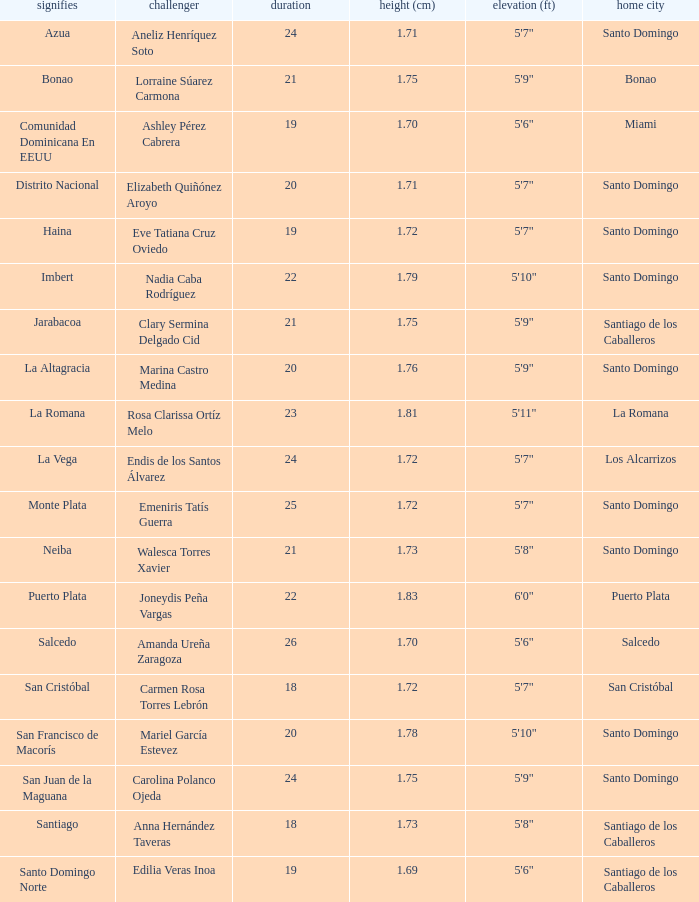Name the least age for distrito nacional 20.0. 